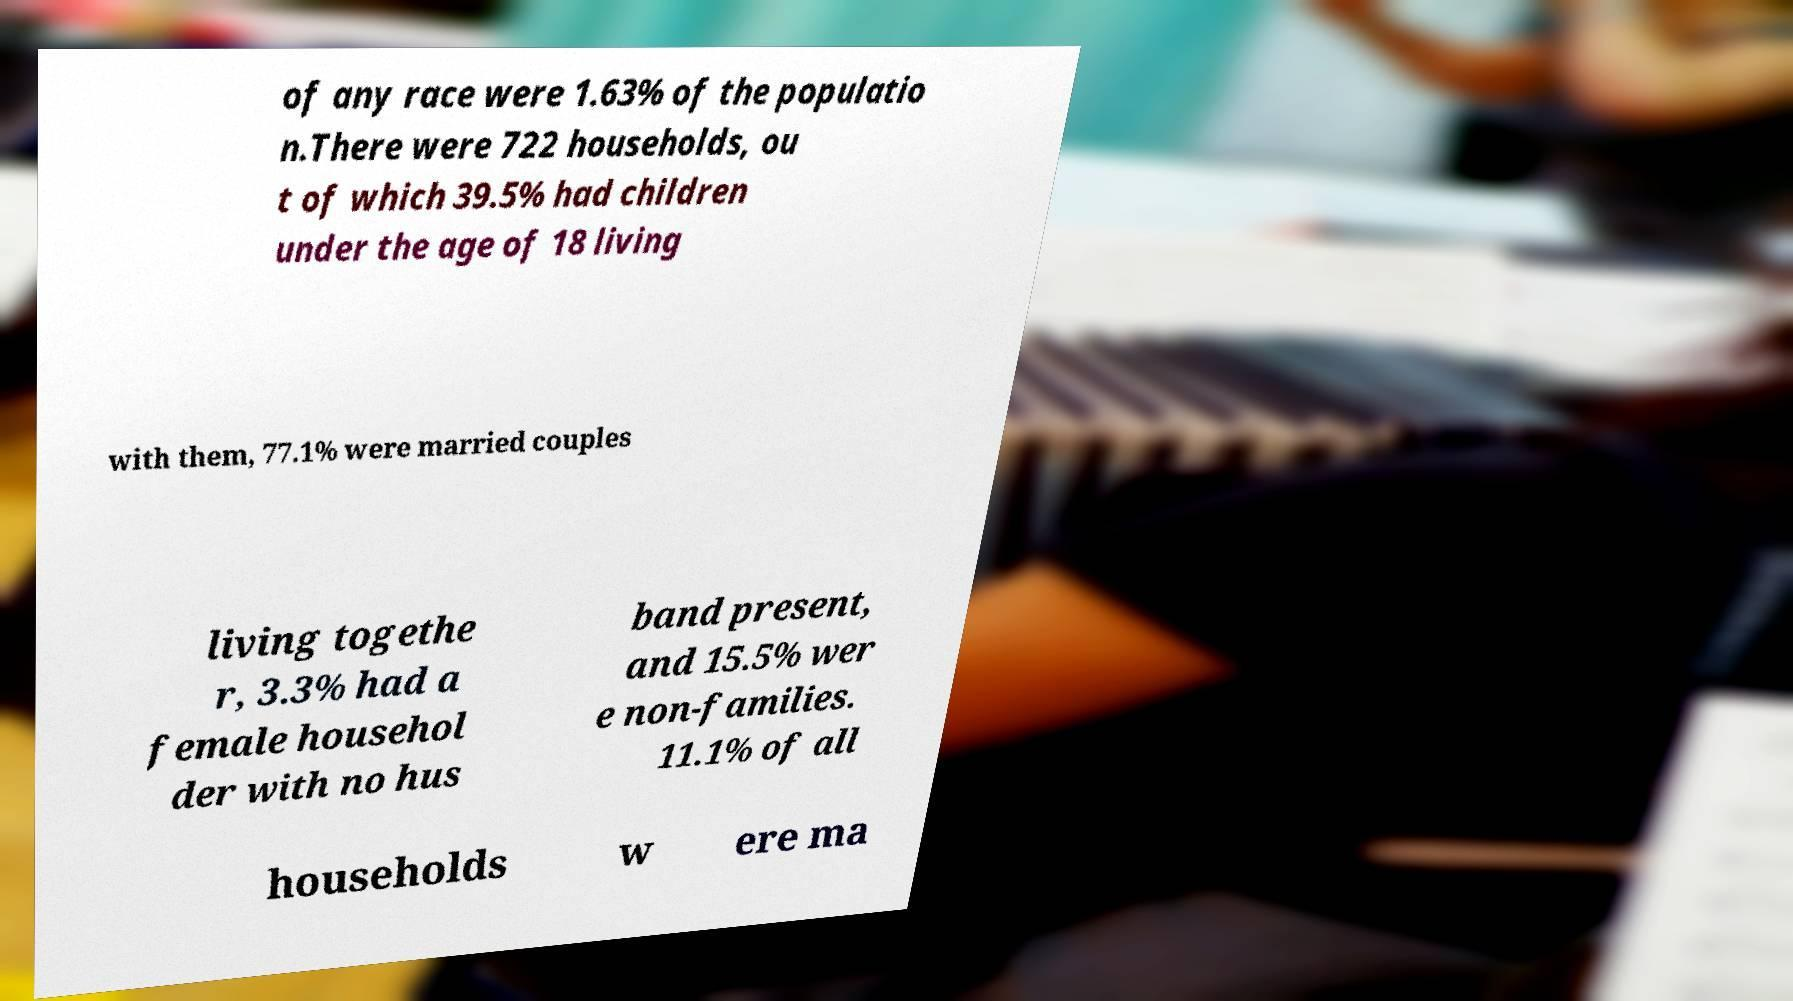Can you accurately transcribe the text from the provided image for me? of any race were 1.63% of the populatio n.There were 722 households, ou t of which 39.5% had children under the age of 18 living with them, 77.1% were married couples living togethe r, 3.3% had a female househol der with no hus band present, and 15.5% wer e non-families. 11.1% of all households w ere ma 